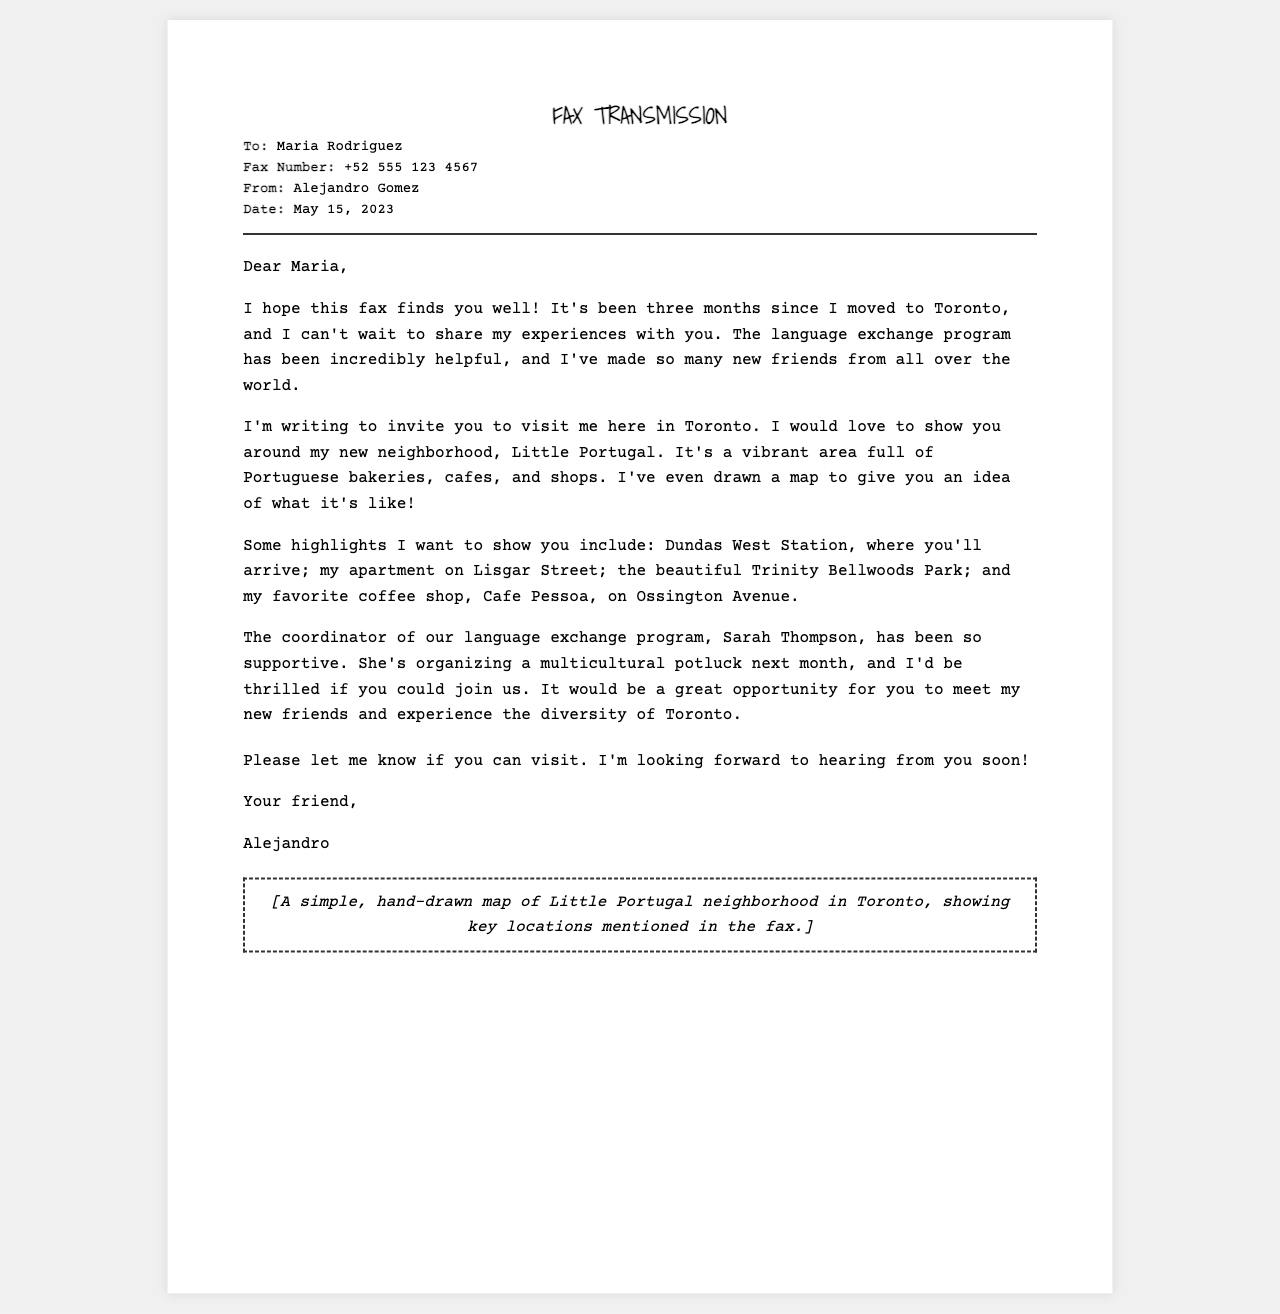What is the recipient's name? The recipient's name is mentioned in the fax header.
Answer: Maria Rodriguez Who is the sender of the fax? The sender's name is indicated in the fax header.
Answer: Alejandro Gomez What is the fax date? The date of the fax is stated in the document.
Answer: May 15, 2023 What neighborhood is Alejandro inviting Maria to visit? The neighborhood mentioned in the invitation is part of the main content.
Answer: Little Portugal What is the name of Alejandro's favorite coffee shop? The coffee shop's name is provided in the list of highlights.
Answer: Cafe Pessoa Who is organizing the multicultural potluck? The person organizing the event is mentioned within the context of the language exchange program.
Answer: Sarah Thompson How many months has Alejandro been in Toronto? The duration mentioned in the first paragraph indicates his time since moving.
Answer: Three months What type of program has Alejandro participated in? The type of program is referenced in the introduction of the document.
Answer: Language exchange program What is included in the document besides the text? The document mentions a specific visual element included at the end.
Answer: Hand-drawn map 